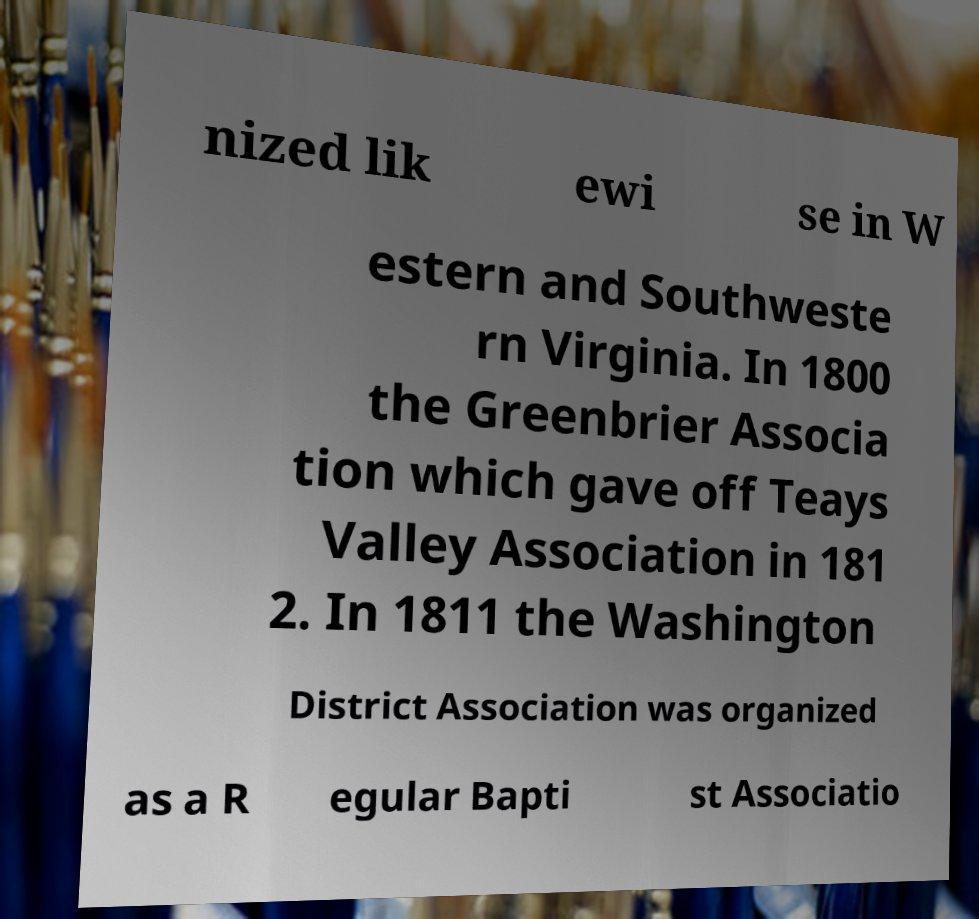There's text embedded in this image that I need extracted. Can you transcribe it verbatim? nized lik ewi se in W estern and Southweste rn Virginia. In 1800 the Greenbrier Associa tion which gave off Teays Valley Association in 181 2. In 1811 the Washington District Association was organized as a R egular Bapti st Associatio 